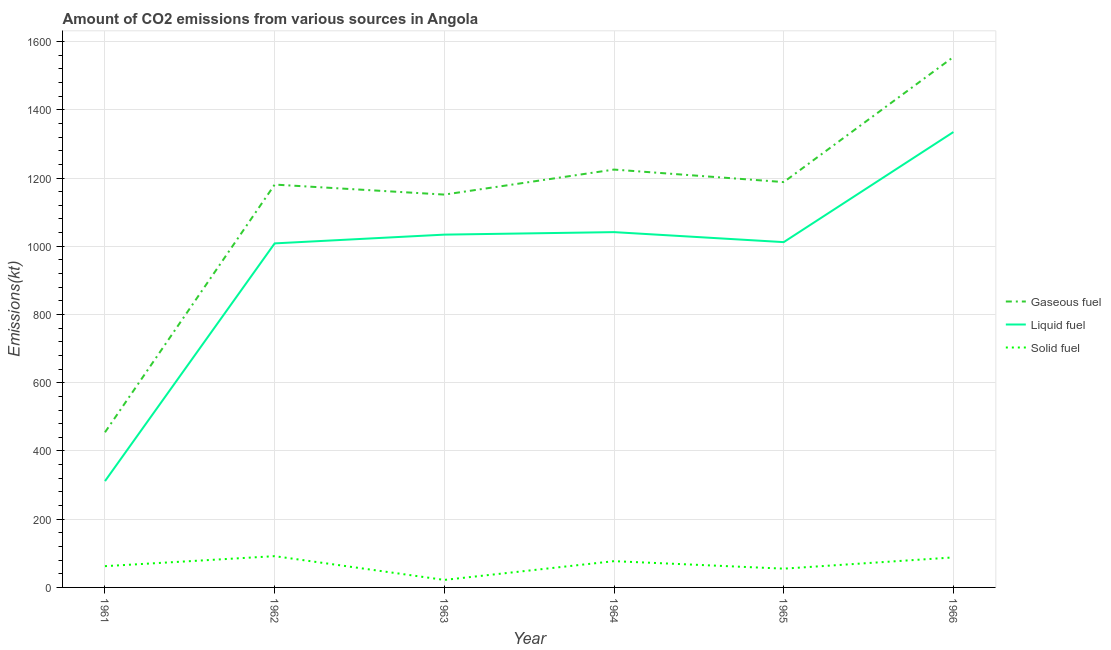Does the line corresponding to amount of co2 emissions from solid fuel intersect with the line corresponding to amount of co2 emissions from gaseous fuel?
Your response must be concise. No. Is the number of lines equal to the number of legend labels?
Your response must be concise. Yes. What is the amount of co2 emissions from solid fuel in 1964?
Offer a very short reply. 77.01. Across all years, what is the maximum amount of co2 emissions from gaseous fuel?
Offer a very short reply. 1554.81. Across all years, what is the minimum amount of co2 emissions from gaseous fuel?
Give a very brief answer. 454.71. In which year was the amount of co2 emissions from solid fuel maximum?
Ensure brevity in your answer.  1962. In which year was the amount of co2 emissions from gaseous fuel minimum?
Make the answer very short. 1961. What is the total amount of co2 emissions from liquid fuel in the graph?
Your response must be concise. 5742.52. What is the difference between the amount of co2 emissions from liquid fuel in 1964 and that in 1965?
Offer a very short reply. 29.34. What is the difference between the amount of co2 emissions from gaseous fuel in 1962 and the amount of co2 emissions from liquid fuel in 1966?
Provide a succinct answer. -154.01. What is the average amount of co2 emissions from gaseous fuel per year?
Provide a short and direct response. 1125.77. In the year 1963, what is the difference between the amount of co2 emissions from liquid fuel and amount of co2 emissions from solid fuel?
Offer a very short reply. 1012.09. What is the ratio of the amount of co2 emissions from gaseous fuel in 1963 to that in 1966?
Your answer should be compact. 0.74. Is the difference between the amount of co2 emissions from liquid fuel in 1964 and 1965 greater than the difference between the amount of co2 emissions from solid fuel in 1964 and 1965?
Provide a succinct answer. Yes. What is the difference between the highest and the second highest amount of co2 emissions from solid fuel?
Provide a succinct answer. 3.67. What is the difference between the highest and the lowest amount of co2 emissions from liquid fuel?
Offer a very short reply. 1023.09. In how many years, is the amount of co2 emissions from gaseous fuel greater than the average amount of co2 emissions from gaseous fuel taken over all years?
Ensure brevity in your answer.  5. Is the sum of the amount of co2 emissions from gaseous fuel in 1961 and 1962 greater than the maximum amount of co2 emissions from solid fuel across all years?
Your answer should be compact. Yes. Is the amount of co2 emissions from gaseous fuel strictly greater than the amount of co2 emissions from solid fuel over the years?
Give a very brief answer. Yes. How many years are there in the graph?
Ensure brevity in your answer.  6. What is the difference between two consecutive major ticks on the Y-axis?
Provide a short and direct response. 200. Are the values on the major ticks of Y-axis written in scientific E-notation?
Keep it short and to the point. No. Does the graph contain any zero values?
Offer a terse response. No. Does the graph contain grids?
Provide a short and direct response. Yes. Where does the legend appear in the graph?
Your answer should be compact. Center right. How are the legend labels stacked?
Give a very brief answer. Vertical. What is the title of the graph?
Keep it short and to the point. Amount of CO2 emissions from various sources in Angola. Does "Consumption Tax" appear as one of the legend labels in the graph?
Offer a terse response. No. What is the label or title of the X-axis?
Offer a terse response. Year. What is the label or title of the Y-axis?
Provide a succinct answer. Emissions(kt). What is the Emissions(kt) in Gaseous fuel in 1961?
Keep it short and to the point. 454.71. What is the Emissions(kt) in Liquid fuel in 1961?
Offer a terse response. 311.69. What is the Emissions(kt) of Solid fuel in 1961?
Give a very brief answer. 62.34. What is the Emissions(kt) of Gaseous fuel in 1962?
Offer a terse response. 1180.77. What is the Emissions(kt) in Liquid fuel in 1962?
Ensure brevity in your answer.  1008.42. What is the Emissions(kt) of Solid fuel in 1962?
Your answer should be very brief. 91.67. What is the Emissions(kt) in Gaseous fuel in 1963?
Your answer should be very brief. 1151.44. What is the Emissions(kt) of Liquid fuel in 1963?
Your response must be concise. 1034.09. What is the Emissions(kt) of Solid fuel in 1963?
Offer a very short reply. 22. What is the Emissions(kt) in Gaseous fuel in 1964?
Give a very brief answer. 1224.78. What is the Emissions(kt) of Liquid fuel in 1964?
Offer a very short reply. 1041.43. What is the Emissions(kt) of Solid fuel in 1964?
Your answer should be compact. 77.01. What is the Emissions(kt) in Gaseous fuel in 1965?
Your response must be concise. 1188.11. What is the Emissions(kt) in Liquid fuel in 1965?
Keep it short and to the point. 1012.09. What is the Emissions(kt) of Solid fuel in 1965?
Offer a terse response. 55.01. What is the Emissions(kt) of Gaseous fuel in 1966?
Keep it short and to the point. 1554.81. What is the Emissions(kt) of Liquid fuel in 1966?
Keep it short and to the point. 1334.79. What is the Emissions(kt) in Solid fuel in 1966?
Offer a terse response. 88.01. Across all years, what is the maximum Emissions(kt) in Gaseous fuel?
Provide a short and direct response. 1554.81. Across all years, what is the maximum Emissions(kt) in Liquid fuel?
Your answer should be very brief. 1334.79. Across all years, what is the maximum Emissions(kt) of Solid fuel?
Your response must be concise. 91.67. Across all years, what is the minimum Emissions(kt) of Gaseous fuel?
Make the answer very short. 454.71. Across all years, what is the minimum Emissions(kt) in Liquid fuel?
Provide a succinct answer. 311.69. Across all years, what is the minimum Emissions(kt) in Solid fuel?
Make the answer very short. 22. What is the total Emissions(kt) of Gaseous fuel in the graph?
Ensure brevity in your answer.  6754.61. What is the total Emissions(kt) of Liquid fuel in the graph?
Keep it short and to the point. 5742.52. What is the total Emissions(kt) in Solid fuel in the graph?
Your answer should be very brief. 396.04. What is the difference between the Emissions(kt) of Gaseous fuel in 1961 and that in 1962?
Keep it short and to the point. -726.07. What is the difference between the Emissions(kt) in Liquid fuel in 1961 and that in 1962?
Provide a short and direct response. -696.73. What is the difference between the Emissions(kt) in Solid fuel in 1961 and that in 1962?
Provide a short and direct response. -29.34. What is the difference between the Emissions(kt) in Gaseous fuel in 1961 and that in 1963?
Provide a succinct answer. -696.73. What is the difference between the Emissions(kt) of Liquid fuel in 1961 and that in 1963?
Your answer should be very brief. -722.4. What is the difference between the Emissions(kt) of Solid fuel in 1961 and that in 1963?
Offer a terse response. 40.34. What is the difference between the Emissions(kt) in Gaseous fuel in 1961 and that in 1964?
Offer a very short reply. -770.07. What is the difference between the Emissions(kt) in Liquid fuel in 1961 and that in 1964?
Offer a very short reply. -729.73. What is the difference between the Emissions(kt) of Solid fuel in 1961 and that in 1964?
Offer a terse response. -14.67. What is the difference between the Emissions(kt) in Gaseous fuel in 1961 and that in 1965?
Your answer should be very brief. -733.4. What is the difference between the Emissions(kt) in Liquid fuel in 1961 and that in 1965?
Offer a terse response. -700.4. What is the difference between the Emissions(kt) in Solid fuel in 1961 and that in 1965?
Give a very brief answer. 7.33. What is the difference between the Emissions(kt) of Gaseous fuel in 1961 and that in 1966?
Give a very brief answer. -1100.1. What is the difference between the Emissions(kt) in Liquid fuel in 1961 and that in 1966?
Offer a very short reply. -1023.09. What is the difference between the Emissions(kt) in Solid fuel in 1961 and that in 1966?
Your answer should be very brief. -25.67. What is the difference between the Emissions(kt) in Gaseous fuel in 1962 and that in 1963?
Keep it short and to the point. 29.34. What is the difference between the Emissions(kt) in Liquid fuel in 1962 and that in 1963?
Give a very brief answer. -25.67. What is the difference between the Emissions(kt) of Solid fuel in 1962 and that in 1963?
Keep it short and to the point. 69.67. What is the difference between the Emissions(kt) in Gaseous fuel in 1962 and that in 1964?
Provide a short and direct response. -44. What is the difference between the Emissions(kt) in Liquid fuel in 1962 and that in 1964?
Ensure brevity in your answer.  -33. What is the difference between the Emissions(kt) in Solid fuel in 1962 and that in 1964?
Make the answer very short. 14.67. What is the difference between the Emissions(kt) of Gaseous fuel in 1962 and that in 1965?
Keep it short and to the point. -7.33. What is the difference between the Emissions(kt) in Liquid fuel in 1962 and that in 1965?
Give a very brief answer. -3.67. What is the difference between the Emissions(kt) in Solid fuel in 1962 and that in 1965?
Give a very brief answer. 36.67. What is the difference between the Emissions(kt) in Gaseous fuel in 1962 and that in 1966?
Ensure brevity in your answer.  -374.03. What is the difference between the Emissions(kt) in Liquid fuel in 1962 and that in 1966?
Make the answer very short. -326.36. What is the difference between the Emissions(kt) of Solid fuel in 1962 and that in 1966?
Your response must be concise. 3.67. What is the difference between the Emissions(kt) in Gaseous fuel in 1963 and that in 1964?
Provide a succinct answer. -73.34. What is the difference between the Emissions(kt) of Liquid fuel in 1963 and that in 1964?
Your answer should be compact. -7.33. What is the difference between the Emissions(kt) in Solid fuel in 1963 and that in 1964?
Provide a short and direct response. -55.01. What is the difference between the Emissions(kt) of Gaseous fuel in 1963 and that in 1965?
Provide a short and direct response. -36.67. What is the difference between the Emissions(kt) in Liquid fuel in 1963 and that in 1965?
Keep it short and to the point. 22. What is the difference between the Emissions(kt) in Solid fuel in 1963 and that in 1965?
Your answer should be compact. -33. What is the difference between the Emissions(kt) of Gaseous fuel in 1963 and that in 1966?
Your answer should be compact. -403.37. What is the difference between the Emissions(kt) in Liquid fuel in 1963 and that in 1966?
Offer a very short reply. -300.69. What is the difference between the Emissions(kt) in Solid fuel in 1963 and that in 1966?
Give a very brief answer. -66.01. What is the difference between the Emissions(kt) of Gaseous fuel in 1964 and that in 1965?
Keep it short and to the point. 36.67. What is the difference between the Emissions(kt) of Liquid fuel in 1964 and that in 1965?
Keep it short and to the point. 29.34. What is the difference between the Emissions(kt) of Solid fuel in 1964 and that in 1965?
Offer a terse response. 22. What is the difference between the Emissions(kt) of Gaseous fuel in 1964 and that in 1966?
Provide a succinct answer. -330.03. What is the difference between the Emissions(kt) of Liquid fuel in 1964 and that in 1966?
Your answer should be very brief. -293.36. What is the difference between the Emissions(kt) in Solid fuel in 1964 and that in 1966?
Offer a terse response. -11. What is the difference between the Emissions(kt) of Gaseous fuel in 1965 and that in 1966?
Your answer should be very brief. -366.7. What is the difference between the Emissions(kt) of Liquid fuel in 1965 and that in 1966?
Offer a very short reply. -322.7. What is the difference between the Emissions(kt) in Solid fuel in 1965 and that in 1966?
Your answer should be very brief. -33. What is the difference between the Emissions(kt) in Gaseous fuel in 1961 and the Emissions(kt) in Liquid fuel in 1962?
Provide a succinct answer. -553.72. What is the difference between the Emissions(kt) in Gaseous fuel in 1961 and the Emissions(kt) in Solid fuel in 1962?
Your response must be concise. 363.03. What is the difference between the Emissions(kt) in Liquid fuel in 1961 and the Emissions(kt) in Solid fuel in 1962?
Keep it short and to the point. 220.02. What is the difference between the Emissions(kt) in Gaseous fuel in 1961 and the Emissions(kt) in Liquid fuel in 1963?
Your answer should be compact. -579.39. What is the difference between the Emissions(kt) in Gaseous fuel in 1961 and the Emissions(kt) in Solid fuel in 1963?
Offer a terse response. 432.71. What is the difference between the Emissions(kt) in Liquid fuel in 1961 and the Emissions(kt) in Solid fuel in 1963?
Make the answer very short. 289.69. What is the difference between the Emissions(kt) in Gaseous fuel in 1961 and the Emissions(kt) in Liquid fuel in 1964?
Your answer should be very brief. -586.72. What is the difference between the Emissions(kt) in Gaseous fuel in 1961 and the Emissions(kt) in Solid fuel in 1964?
Your answer should be compact. 377.7. What is the difference between the Emissions(kt) in Liquid fuel in 1961 and the Emissions(kt) in Solid fuel in 1964?
Give a very brief answer. 234.69. What is the difference between the Emissions(kt) in Gaseous fuel in 1961 and the Emissions(kt) in Liquid fuel in 1965?
Ensure brevity in your answer.  -557.38. What is the difference between the Emissions(kt) in Gaseous fuel in 1961 and the Emissions(kt) in Solid fuel in 1965?
Offer a very short reply. 399.7. What is the difference between the Emissions(kt) of Liquid fuel in 1961 and the Emissions(kt) of Solid fuel in 1965?
Offer a terse response. 256.69. What is the difference between the Emissions(kt) of Gaseous fuel in 1961 and the Emissions(kt) of Liquid fuel in 1966?
Provide a short and direct response. -880.08. What is the difference between the Emissions(kt) in Gaseous fuel in 1961 and the Emissions(kt) in Solid fuel in 1966?
Give a very brief answer. 366.7. What is the difference between the Emissions(kt) in Liquid fuel in 1961 and the Emissions(kt) in Solid fuel in 1966?
Provide a succinct answer. 223.69. What is the difference between the Emissions(kt) in Gaseous fuel in 1962 and the Emissions(kt) in Liquid fuel in 1963?
Your answer should be very brief. 146.68. What is the difference between the Emissions(kt) of Gaseous fuel in 1962 and the Emissions(kt) of Solid fuel in 1963?
Ensure brevity in your answer.  1158.77. What is the difference between the Emissions(kt) of Liquid fuel in 1962 and the Emissions(kt) of Solid fuel in 1963?
Your answer should be compact. 986.42. What is the difference between the Emissions(kt) of Gaseous fuel in 1962 and the Emissions(kt) of Liquid fuel in 1964?
Ensure brevity in your answer.  139.35. What is the difference between the Emissions(kt) of Gaseous fuel in 1962 and the Emissions(kt) of Solid fuel in 1964?
Ensure brevity in your answer.  1103.77. What is the difference between the Emissions(kt) in Liquid fuel in 1962 and the Emissions(kt) in Solid fuel in 1964?
Your answer should be very brief. 931.42. What is the difference between the Emissions(kt) of Gaseous fuel in 1962 and the Emissions(kt) of Liquid fuel in 1965?
Keep it short and to the point. 168.68. What is the difference between the Emissions(kt) of Gaseous fuel in 1962 and the Emissions(kt) of Solid fuel in 1965?
Offer a terse response. 1125.77. What is the difference between the Emissions(kt) in Liquid fuel in 1962 and the Emissions(kt) in Solid fuel in 1965?
Give a very brief answer. 953.42. What is the difference between the Emissions(kt) in Gaseous fuel in 1962 and the Emissions(kt) in Liquid fuel in 1966?
Ensure brevity in your answer.  -154.01. What is the difference between the Emissions(kt) in Gaseous fuel in 1962 and the Emissions(kt) in Solid fuel in 1966?
Your response must be concise. 1092.77. What is the difference between the Emissions(kt) of Liquid fuel in 1962 and the Emissions(kt) of Solid fuel in 1966?
Make the answer very short. 920.42. What is the difference between the Emissions(kt) of Gaseous fuel in 1963 and the Emissions(kt) of Liquid fuel in 1964?
Ensure brevity in your answer.  110.01. What is the difference between the Emissions(kt) in Gaseous fuel in 1963 and the Emissions(kt) in Solid fuel in 1964?
Offer a terse response. 1074.43. What is the difference between the Emissions(kt) of Liquid fuel in 1963 and the Emissions(kt) of Solid fuel in 1964?
Make the answer very short. 957.09. What is the difference between the Emissions(kt) of Gaseous fuel in 1963 and the Emissions(kt) of Liquid fuel in 1965?
Provide a short and direct response. 139.35. What is the difference between the Emissions(kt) in Gaseous fuel in 1963 and the Emissions(kt) in Solid fuel in 1965?
Your response must be concise. 1096.43. What is the difference between the Emissions(kt) of Liquid fuel in 1963 and the Emissions(kt) of Solid fuel in 1965?
Your response must be concise. 979.09. What is the difference between the Emissions(kt) of Gaseous fuel in 1963 and the Emissions(kt) of Liquid fuel in 1966?
Ensure brevity in your answer.  -183.35. What is the difference between the Emissions(kt) of Gaseous fuel in 1963 and the Emissions(kt) of Solid fuel in 1966?
Your response must be concise. 1063.43. What is the difference between the Emissions(kt) in Liquid fuel in 1963 and the Emissions(kt) in Solid fuel in 1966?
Offer a very short reply. 946.09. What is the difference between the Emissions(kt) of Gaseous fuel in 1964 and the Emissions(kt) of Liquid fuel in 1965?
Your answer should be compact. 212.69. What is the difference between the Emissions(kt) in Gaseous fuel in 1964 and the Emissions(kt) in Solid fuel in 1965?
Give a very brief answer. 1169.77. What is the difference between the Emissions(kt) of Liquid fuel in 1964 and the Emissions(kt) of Solid fuel in 1965?
Give a very brief answer. 986.42. What is the difference between the Emissions(kt) in Gaseous fuel in 1964 and the Emissions(kt) in Liquid fuel in 1966?
Offer a very short reply. -110.01. What is the difference between the Emissions(kt) of Gaseous fuel in 1964 and the Emissions(kt) of Solid fuel in 1966?
Offer a terse response. 1136.77. What is the difference between the Emissions(kt) of Liquid fuel in 1964 and the Emissions(kt) of Solid fuel in 1966?
Your answer should be compact. 953.42. What is the difference between the Emissions(kt) in Gaseous fuel in 1965 and the Emissions(kt) in Liquid fuel in 1966?
Your answer should be compact. -146.68. What is the difference between the Emissions(kt) of Gaseous fuel in 1965 and the Emissions(kt) of Solid fuel in 1966?
Give a very brief answer. 1100.1. What is the difference between the Emissions(kt) in Liquid fuel in 1965 and the Emissions(kt) in Solid fuel in 1966?
Your response must be concise. 924.08. What is the average Emissions(kt) of Gaseous fuel per year?
Your answer should be compact. 1125.77. What is the average Emissions(kt) in Liquid fuel per year?
Offer a terse response. 957.09. What is the average Emissions(kt) in Solid fuel per year?
Make the answer very short. 66.01. In the year 1961, what is the difference between the Emissions(kt) in Gaseous fuel and Emissions(kt) in Liquid fuel?
Your answer should be very brief. 143.01. In the year 1961, what is the difference between the Emissions(kt) in Gaseous fuel and Emissions(kt) in Solid fuel?
Offer a very short reply. 392.37. In the year 1961, what is the difference between the Emissions(kt) in Liquid fuel and Emissions(kt) in Solid fuel?
Keep it short and to the point. 249.36. In the year 1962, what is the difference between the Emissions(kt) of Gaseous fuel and Emissions(kt) of Liquid fuel?
Offer a terse response. 172.35. In the year 1962, what is the difference between the Emissions(kt) of Gaseous fuel and Emissions(kt) of Solid fuel?
Your answer should be very brief. 1089.1. In the year 1962, what is the difference between the Emissions(kt) of Liquid fuel and Emissions(kt) of Solid fuel?
Provide a short and direct response. 916.75. In the year 1963, what is the difference between the Emissions(kt) of Gaseous fuel and Emissions(kt) of Liquid fuel?
Your answer should be compact. 117.34. In the year 1963, what is the difference between the Emissions(kt) of Gaseous fuel and Emissions(kt) of Solid fuel?
Give a very brief answer. 1129.44. In the year 1963, what is the difference between the Emissions(kt) of Liquid fuel and Emissions(kt) of Solid fuel?
Keep it short and to the point. 1012.09. In the year 1964, what is the difference between the Emissions(kt) of Gaseous fuel and Emissions(kt) of Liquid fuel?
Make the answer very short. 183.35. In the year 1964, what is the difference between the Emissions(kt) in Gaseous fuel and Emissions(kt) in Solid fuel?
Your answer should be compact. 1147.77. In the year 1964, what is the difference between the Emissions(kt) of Liquid fuel and Emissions(kt) of Solid fuel?
Keep it short and to the point. 964.42. In the year 1965, what is the difference between the Emissions(kt) of Gaseous fuel and Emissions(kt) of Liquid fuel?
Give a very brief answer. 176.02. In the year 1965, what is the difference between the Emissions(kt) in Gaseous fuel and Emissions(kt) in Solid fuel?
Ensure brevity in your answer.  1133.1. In the year 1965, what is the difference between the Emissions(kt) of Liquid fuel and Emissions(kt) of Solid fuel?
Your answer should be very brief. 957.09. In the year 1966, what is the difference between the Emissions(kt) in Gaseous fuel and Emissions(kt) in Liquid fuel?
Provide a short and direct response. 220.02. In the year 1966, what is the difference between the Emissions(kt) of Gaseous fuel and Emissions(kt) of Solid fuel?
Provide a short and direct response. 1466.8. In the year 1966, what is the difference between the Emissions(kt) of Liquid fuel and Emissions(kt) of Solid fuel?
Offer a very short reply. 1246.78. What is the ratio of the Emissions(kt) in Gaseous fuel in 1961 to that in 1962?
Provide a short and direct response. 0.39. What is the ratio of the Emissions(kt) of Liquid fuel in 1961 to that in 1962?
Keep it short and to the point. 0.31. What is the ratio of the Emissions(kt) of Solid fuel in 1961 to that in 1962?
Provide a short and direct response. 0.68. What is the ratio of the Emissions(kt) of Gaseous fuel in 1961 to that in 1963?
Ensure brevity in your answer.  0.39. What is the ratio of the Emissions(kt) in Liquid fuel in 1961 to that in 1963?
Offer a terse response. 0.3. What is the ratio of the Emissions(kt) in Solid fuel in 1961 to that in 1963?
Ensure brevity in your answer.  2.83. What is the ratio of the Emissions(kt) of Gaseous fuel in 1961 to that in 1964?
Offer a terse response. 0.37. What is the ratio of the Emissions(kt) of Liquid fuel in 1961 to that in 1964?
Offer a very short reply. 0.3. What is the ratio of the Emissions(kt) of Solid fuel in 1961 to that in 1964?
Your answer should be very brief. 0.81. What is the ratio of the Emissions(kt) of Gaseous fuel in 1961 to that in 1965?
Keep it short and to the point. 0.38. What is the ratio of the Emissions(kt) in Liquid fuel in 1961 to that in 1965?
Provide a succinct answer. 0.31. What is the ratio of the Emissions(kt) in Solid fuel in 1961 to that in 1965?
Offer a terse response. 1.13. What is the ratio of the Emissions(kt) in Gaseous fuel in 1961 to that in 1966?
Provide a short and direct response. 0.29. What is the ratio of the Emissions(kt) of Liquid fuel in 1961 to that in 1966?
Provide a short and direct response. 0.23. What is the ratio of the Emissions(kt) of Solid fuel in 1961 to that in 1966?
Offer a terse response. 0.71. What is the ratio of the Emissions(kt) of Gaseous fuel in 1962 to that in 1963?
Your answer should be very brief. 1.03. What is the ratio of the Emissions(kt) in Liquid fuel in 1962 to that in 1963?
Your answer should be very brief. 0.98. What is the ratio of the Emissions(kt) in Solid fuel in 1962 to that in 1963?
Keep it short and to the point. 4.17. What is the ratio of the Emissions(kt) in Gaseous fuel in 1962 to that in 1964?
Ensure brevity in your answer.  0.96. What is the ratio of the Emissions(kt) in Liquid fuel in 1962 to that in 1964?
Your answer should be very brief. 0.97. What is the ratio of the Emissions(kt) of Solid fuel in 1962 to that in 1964?
Ensure brevity in your answer.  1.19. What is the ratio of the Emissions(kt) of Liquid fuel in 1962 to that in 1965?
Your answer should be compact. 1. What is the ratio of the Emissions(kt) of Solid fuel in 1962 to that in 1965?
Offer a terse response. 1.67. What is the ratio of the Emissions(kt) of Gaseous fuel in 1962 to that in 1966?
Provide a succinct answer. 0.76. What is the ratio of the Emissions(kt) of Liquid fuel in 1962 to that in 1966?
Your answer should be very brief. 0.76. What is the ratio of the Emissions(kt) of Solid fuel in 1962 to that in 1966?
Provide a short and direct response. 1.04. What is the ratio of the Emissions(kt) in Gaseous fuel in 1963 to that in 1964?
Offer a terse response. 0.94. What is the ratio of the Emissions(kt) of Solid fuel in 1963 to that in 1964?
Your answer should be compact. 0.29. What is the ratio of the Emissions(kt) in Gaseous fuel in 1963 to that in 1965?
Your response must be concise. 0.97. What is the ratio of the Emissions(kt) in Liquid fuel in 1963 to that in 1965?
Provide a short and direct response. 1.02. What is the ratio of the Emissions(kt) of Solid fuel in 1963 to that in 1965?
Make the answer very short. 0.4. What is the ratio of the Emissions(kt) in Gaseous fuel in 1963 to that in 1966?
Give a very brief answer. 0.74. What is the ratio of the Emissions(kt) in Liquid fuel in 1963 to that in 1966?
Your answer should be compact. 0.77. What is the ratio of the Emissions(kt) in Gaseous fuel in 1964 to that in 1965?
Your answer should be very brief. 1.03. What is the ratio of the Emissions(kt) in Solid fuel in 1964 to that in 1965?
Offer a very short reply. 1.4. What is the ratio of the Emissions(kt) of Gaseous fuel in 1964 to that in 1966?
Your answer should be compact. 0.79. What is the ratio of the Emissions(kt) in Liquid fuel in 1964 to that in 1966?
Provide a short and direct response. 0.78. What is the ratio of the Emissions(kt) of Solid fuel in 1964 to that in 1966?
Make the answer very short. 0.88. What is the ratio of the Emissions(kt) of Gaseous fuel in 1965 to that in 1966?
Offer a terse response. 0.76. What is the ratio of the Emissions(kt) of Liquid fuel in 1965 to that in 1966?
Offer a terse response. 0.76. What is the ratio of the Emissions(kt) of Solid fuel in 1965 to that in 1966?
Ensure brevity in your answer.  0.62. What is the difference between the highest and the second highest Emissions(kt) in Gaseous fuel?
Provide a short and direct response. 330.03. What is the difference between the highest and the second highest Emissions(kt) of Liquid fuel?
Your answer should be very brief. 293.36. What is the difference between the highest and the second highest Emissions(kt) in Solid fuel?
Provide a succinct answer. 3.67. What is the difference between the highest and the lowest Emissions(kt) of Gaseous fuel?
Provide a short and direct response. 1100.1. What is the difference between the highest and the lowest Emissions(kt) in Liquid fuel?
Give a very brief answer. 1023.09. What is the difference between the highest and the lowest Emissions(kt) of Solid fuel?
Provide a short and direct response. 69.67. 